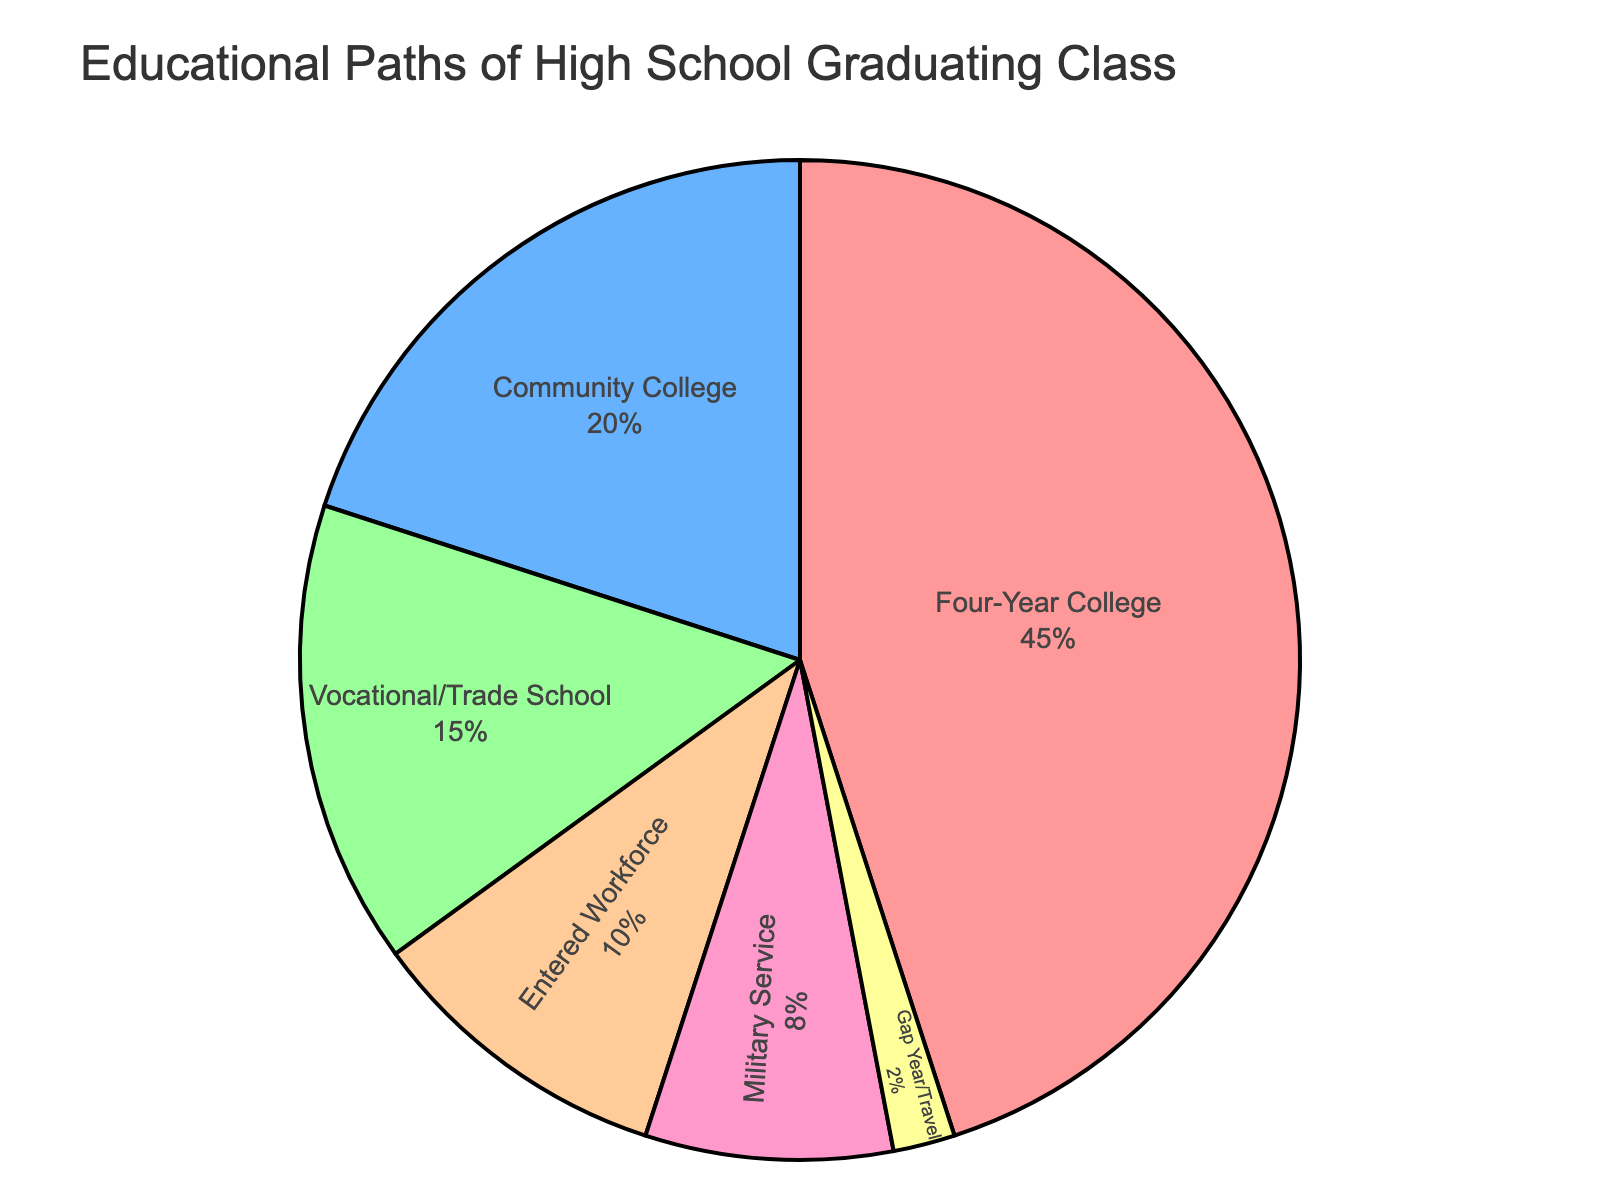What percentage of your high school graduating class attended a four-year college? Look at the pie chart and find the segment labeled 'Four-Year College'. The percentage next to it is 45%.
Answer: 45% How many combined students went into Community College and Vocational/Trade School? Add the percentage of students who went to Community College (20%) to those who attended Vocational/Trade School (15%). This sum is 20% + 15% = 35%.
Answer: 35% Which educational path had the least number of students? Examine the pie chart and note the smallest segment which is labeled 'Gap Year/Travel' with a percentage value of 2%.
Answer: Gap Year/Travel Did more students enter the workforce immediately or join the military? Compare the segments labeled 'Entered Workforce' at 10% and 'Military Service' at 8%. 10% is greater than 8%, so more students entered the workforce.
Answer: Entered Workforce What is the total percentage of students who pursued higher education (Four-Year College, Community College, Vocational/Trade School)? Add the percentages of students who went to Four-Year College (45%), Community College (20%), and Vocational/Trade School (15%). The total is 45% + 20% + 15% = 80%.
Answer: 80% If you exclude those entering the workforce, what is the average percentage of students in the remaining categories? First, subtract the percentage of students who entered the workforce (10%) from the total (100%), resulting in 90%.  Then divide by the number of remaining categories (Five: Four-Year College, Community College, Vocational/Trade School, Military Service, Gap Year/Travel): 90% / 5 = 18%.
Answer: 18% Which educational path had a higher percentage: Military Service or Gap Year/Travel? Compare the segment labeled 'Military Service' at 8% and 'Gap Year/Travel' at 2%. 8% is greater than 2%, so Military Service had a higher percentage.
Answer: Military Service How much larger is the percentage of students attending a Four-Year College compared to those entering the workforce? Subtract the percentage of students entering the workforce (10%) from those attending a Four-Year College (45%): 45% - 10% = 35%.
Answer: 35% 